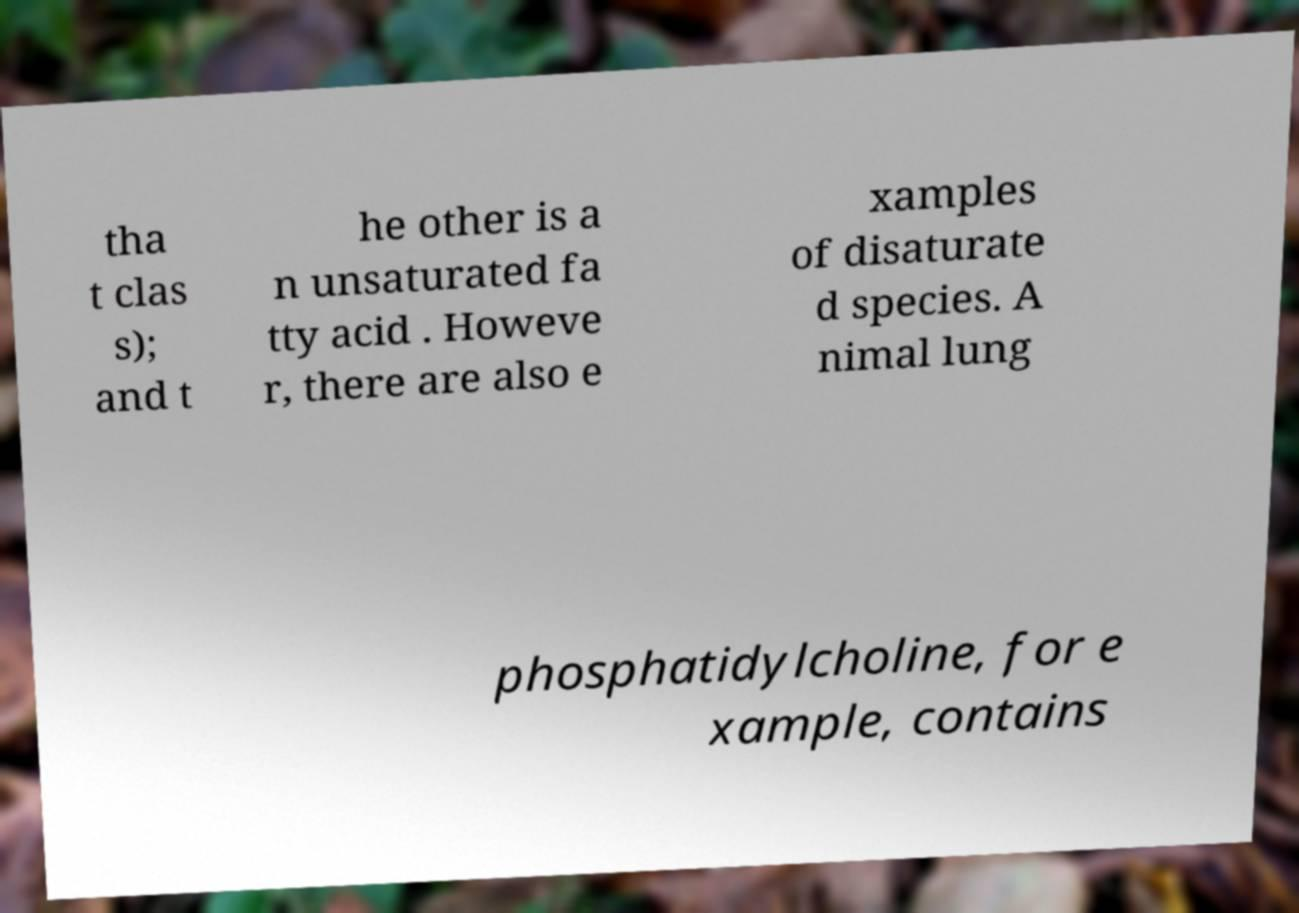For documentation purposes, I need the text within this image transcribed. Could you provide that? tha t clas s); and t he other is a n unsaturated fa tty acid . Howeve r, there are also e xamples of disaturate d species. A nimal lung phosphatidylcholine, for e xample, contains 